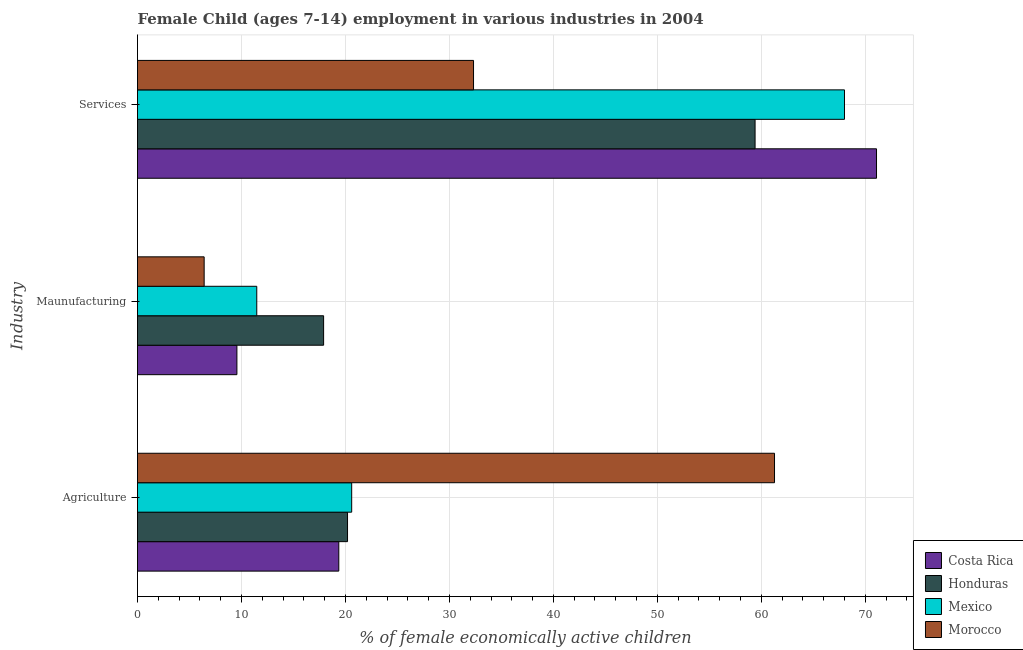How many different coloured bars are there?
Your answer should be compact. 4. How many bars are there on the 2nd tick from the top?
Your response must be concise. 4. What is the label of the 2nd group of bars from the top?
Keep it short and to the point. Maunufacturing. What is the percentage of economically active children in agriculture in Honduras?
Offer a very short reply. 20.2. Across all countries, what is the maximum percentage of economically active children in services?
Offer a very short reply. 71.08. Across all countries, what is the minimum percentage of economically active children in manufacturing?
Offer a terse response. 6.41. In which country was the percentage of economically active children in agriculture maximum?
Your response must be concise. Morocco. What is the total percentage of economically active children in agriculture in the graph?
Your answer should be very brief. 121.43. What is the difference between the percentage of economically active children in agriculture in Costa Rica and that in Morocco?
Your answer should be very brief. -41.91. What is the difference between the percentage of economically active children in agriculture in Morocco and the percentage of economically active children in manufacturing in Honduras?
Your answer should be compact. 43.37. What is the average percentage of economically active children in agriculture per country?
Offer a terse response. 30.36. What is the difference between the percentage of economically active children in services and percentage of economically active children in manufacturing in Mexico?
Give a very brief answer. 56.53. What is the ratio of the percentage of economically active children in manufacturing in Honduras to that in Mexico?
Provide a short and direct response. 1.56. Is the percentage of economically active children in agriculture in Morocco less than that in Honduras?
Your response must be concise. No. What is the difference between the highest and the second highest percentage of economically active children in agriculture?
Ensure brevity in your answer.  40.67. What is the difference between the highest and the lowest percentage of economically active children in services?
Give a very brief answer. 38.76. Is the sum of the percentage of economically active children in agriculture in Mexico and Honduras greater than the maximum percentage of economically active children in manufacturing across all countries?
Make the answer very short. Yes. What does the 3rd bar from the top in Services represents?
Keep it short and to the point. Honduras. What does the 4th bar from the bottom in Maunufacturing represents?
Your answer should be very brief. Morocco. How many bars are there?
Provide a succinct answer. 12. How many countries are there in the graph?
Make the answer very short. 4. What is the difference between two consecutive major ticks on the X-axis?
Provide a succinct answer. 10. Are the values on the major ticks of X-axis written in scientific E-notation?
Give a very brief answer. No. Does the graph contain grids?
Ensure brevity in your answer.  Yes. How many legend labels are there?
Your response must be concise. 4. How are the legend labels stacked?
Ensure brevity in your answer.  Vertical. What is the title of the graph?
Make the answer very short. Female Child (ages 7-14) employment in various industries in 2004. Does "Korea (Republic)" appear as one of the legend labels in the graph?
Make the answer very short. No. What is the label or title of the X-axis?
Make the answer very short. % of female economically active children. What is the label or title of the Y-axis?
Your response must be concise. Industry. What is the % of female economically active children in Costa Rica in Agriculture?
Keep it short and to the point. 19.36. What is the % of female economically active children in Honduras in Agriculture?
Offer a terse response. 20.2. What is the % of female economically active children of Mexico in Agriculture?
Your answer should be compact. 20.6. What is the % of female economically active children of Morocco in Agriculture?
Offer a very short reply. 61.27. What is the % of female economically active children of Costa Rica in Maunufacturing?
Provide a succinct answer. 9.56. What is the % of female economically active children of Mexico in Maunufacturing?
Keep it short and to the point. 11.47. What is the % of female economically active children of Morocco in Maunufacturing?
Offer a terse response. 6.41. What is the % of female economically active children in Costa Rica in Services?
Your response must be concise. 71.08. What is the % of female economically active children in Honduras in Services?
Your answer should be compact. 59.4. What is the % of female economically active children in Mexico in Services?
Give a very brief answer. 68. What is the % of female economically active children in Morocco in Services?
Offer a terse response. 32.32. Across all Industry, what is the maximum % of female economically active children of Costa Rica?
Provide a short and direct response. 71.08. Across all Industry, what is the maximum % of female economically active children of Honduras?
Offer a terse response. 59.4. Across all Industry, what is the maximum % of female economically active children of Morocco?
Provide a succinct answer. 61.27. Across all Industry, what is the minimum % of female economically active children of Costa Rica?
Your answer should be very brief. 9.56. Across all Industry, what is the minimum % of female economically active children in Mexico?
Ensure brevity in your answer.  11.47. Across all Industry, what is the minimum % of female economically active children of Morocco?
Your answer should be compact. 6.41. What is the total % of female economically active children in Costa Rica in the graph?
Your answer should be very brief. 100. What is the total % of female economically active children of Honduras in the graph?
Make the answer very short. 97.5. What is the total % of female economically active children of Mexico in the graph?
Make the answer very short. 100.07. What is the difference between the % of female economically active children in Mexico in Agriculture and that in Maunufacturing?
Offer a terse response. 9.13. What is the difference between the % of female economically active children of Morocco in Agriculture and that in Maunufacturing?
Your answer should be very brief. 54.86. What is the difference between the % of female economically active children of Costa Rica in Agriculture and that in Services?
Your answer should be very brief. -51.72. What is the difference between the % of female economically active children of Honduras in Agriculture and that in Services?
Keep it short and to the point. -39.2. What is the difference between the % of female economically active children of Mexico in Agriculture and that in Services?
Give a very brief answer. -47.4. What is the difference between the % of female economically active children in Morocco in Agriculture and that in Services?
Make the answer very short. 28.95. What is the difference between the % of female economically active children in Costa Rica in Maunufacturing and that in Services?
Give a very brief answer. -61.52. What is the difference between the % of female economically active children in Honduras in Maunufacturing and that in Services?
Your answer should be compact. -41.5. What is the difference between the % of female economically active children in Mexico in Maunufacturing and that in Services?
Give a very brief answer. -56.53. What is the difference between the % of female economically active children in Morocco in Maunufacturing and that in Services?
Provide a succinct answer. -25.91. What is the difference between the % of female economically active children in Costa Rica in Agriculture and the % of female economically active children in Honduras in Maunufacturing?
Give a very brief answer. 1.46. What is the difference between the % of female economically active children in Costa Rica in Agriculture and the % of female economically active children in Mexico in Maunufacturing?
Give a very brief answer. 7.89. What is the difference between the % of female economically active children in Costa Rica in Agriculture and the % of female economically active children in Morocco in Maunufacturing?
Provide a short and direct response. 12.95. What is the difference between the % of female economically active children of Honduras in Agriculture and the % of female economically active children of Mexico in Maunufacturing?
Ensure brevity in your answer.  8.73. What is the difference between the % of female economically active children in Honduras in Agriculture and the % of female economically active children in Morocco in Maunufacturing?
Offer a very short reply. 13.79. What is the difference between the % of female economically active children in Mexico in Agriculture and the % of female economically active children in Morocco in Maunufacturing?
Keep it short and to the point. 14.19. What is the difference between the % of female economically active children in Costa Rica in Agriculture and the % of female economically active children in Honduras in Services?
Your response must be concise. -40.04. What is the difference between the % of female economically active children in Costa Rica in Agriculture and the % of female economically active children in Mexico in Services?
Provide a succinct answer. -48.64. What is the difference between the % of female economically active children in Costa Rica in Agriculture and the % of female economically active children in Morocco in Services?
Offer a terse response. -12.96. What is the difference between the % of female economically active children in Honduras in Agriculture and the % of female economically active children in Mexico in Services?
Your answer should be very brief. -47.8. What is the difference between the % of female economically active children of Honduras in Agriculture and the % of female economically active children of Morocco in Services?
Your answer should be compact. -12.12. What is the difference between the % of female economically active children of Mexico in Agriculture and the % of female economically active children of Morocco in Services?
Offer a very short reply. -11.72. What is the difference between the % of female economically active children in Costa Rica in Maunufacturing and the % of female economically active children in Honduras in Services?
Provide a short and direct response. -49.84. What is the difference between the % of female economically active children of Costa Rica in Maunufacturing and the % of female economically active children of Mexico in Services?
Give a very brief answer. -58.44. What is the difference between the % of female economically active children of Costa Rica in Maunufacturing and the % of female economically active children of Morocco in Services?
Keep it short and to the point. -22.76. What is the difference between the % of female economically active children of Honduras in Maunufacturing and the % of female economically active children of Mexico in Services?
Your answer should be very brief. -50.1. What is the difference between the % of female economically active children of Honduras in Maunufacturing and the % of female economically active children of Morocco in Services?
Offer a very short reply. -14.42. What is the difference between the % of female economically active children of Mexico in Maunufacturing and the % of female economically active children of Morocco in Services?
Ensure brevity in your answer.  -20.85. What is the average % of female economically active children in Costa Rica per Industry?
Your answer should be compact. 33.33. What is the average % of female economically active children in Honduras per Industry?
Provide a succinct answer. 32.5. What is the average % of female economically active children in Mexico per Industry?
Give a very brief answer. 33.36. What is the average % of female economically active children of Morocco per Industry?
Provide a succinct answer. 33.33. What is the difference between the % of female economically active children of Costa Rica and % of female economically active children of Honduras in Agriculture?
Your response must be concise. -0.84. What is the difference between the % of female economically active children of Costa Rica and % of female economically active children of Mexico in Agriculture?
Provide a succinct answer. -1.24. What is the difference between the % of female economically active children of Costa Rica and % of female economically active children of Morocco in Agriculture?
Provide a short and direct response. -41.91. What is the difference between the % of female economically active children of Honduras and % of female economically active children of Mexico in Agriculture?
Offer a very short reply. -0.4. What is the difference between the % of female economically active children of Honduras and % of female economically active children of Morocco in Agriculture?
Keep it short and to the point. -41.07. What is the difference between the % of female economically active children of Mexico and % of female economically active children of Morocco in Agriculture?
Your answer should be very brief. -40.67. What is the difference between the % of female economically active children of Costa Rica and % of female economically active children of Honduras in Maunufacturing?
Provide a short and direct response. -8.34. What is the difference between the % of female economically active children of Costa Rica and % of female economically active children of Mexico in Maunufacturing?
Give a very brief answer. -1.91. What is the difference between the % of female economically active children of Costa Rica and % of female economically active children of Morocco in Maunufacturing?
Provide a succinct answer. 3.15. What is the difference between the % of female economically active children in Honduras and % of female economically active children in Mexico in Maunufacturing?
Give a very brief answer. 6.43. What is the difference between the % of female economically active children in Honduras and % of female economically active children in Morocco in Maunufacturing?
Your answer should be compact. 11.49. What is the difference between the % of female economically active children in Mexico and % of female economically active children in Morocco in Maunufacturing?
Provide a succinct answer. 5.06. What is the difference between the % of female economically active children of Costa Rica and % of female economically active children of Honduras in Services?
Make the answer very short. 11.68. What is the difference between the % of female economically active children in Costa Rica and % of female economically active children in Mexico in Services?
Keep it short and to the point. 3.08. What is the difference between the % of female economically active children in Costa Rica and % of female economically active children in Morocco in Services?
Provide a succinct answer. 38.76. What is the difference between the % of female economically active children of Honduras and % of female economically active children of Morocco in Services?
Provide a succinct answer. 27.08. What is the difference between the % of female economically active children of Mexico and % of female economically active children of Morocco in Services?
Make the answer very short. 35.68. What is the ratio of the % of female economically active children in Costa Rica in Agriculture to that in Maunufacturing?
Make the answer very short. 2.03. What is the ratio of the % of female economically active children in Honduras in Agriculture to that in Maunufacturing?
Keep it short and to the point. 1.13. What is the ratio of the % of female economically active children of Mexico in Agriculture to that in Maunufacturing?
Your answer should be very brief. 1.8. What is the ratio of the % of female economically active children in Morocco in Agriculture to that in Maunufacturing?
Your answer should be very brief. 9.56. What is the ratio of the % of female economically active children of Costa Rica in Agriculture to that in Services?
Offer a terse response. 0.27. What is the ratio of the % of female economically active children in Honduras in Agriculture to that in Services?
Offer a very short reply. 0.34. What is the ratio of the % of female economically active children in Mexico in Agriculture to that in Services?
Your answer should be compact. 0.3. What is the ratio of the % of female economically active children of Morocco in Agriculture to that in Services?
Make the answer very short. 1.9. What is the ratio of the % of female economically active children of Costa Rica in Maunufacturing to that in Services?
Make the answer very short. 0.13. What is the ratio of the % of female economically active children in Honduras in Maunufacturing to that in Services?
Offer a very short reply. 0.3. What is the ratio of the % of female economically active children in Mexico in Maunufacturing to that in Services?
Keep it short and to the point. 0.17. What is the ratio of the % of female economically active children in Morocco in Maunufacturing to that in Services?
Ensure brevity in your answer.  0.2. What is the difference between the highest and the second highest % of female economically active children of Costa Rica?
Keep it short and to the point. 51.72. What is the difference between the highest and the second highest % of female economically active children of Honduras?
Provide a succinct answer. 39.2. What is the difference between the highest and the second highest % of female economically active children of Mexico?
Your response must be concise. 47.4. What is the difference between the highest and the second highest % of female economically active children of Morocco?
Offer a terse response. 28.95. What is the difference between the highest and the lowest % of female economically active children of Costa Rica?
Your response must be concise. 61.52. What is the difference between the highest and the lowest % of female economically active children of Honduras?
Keep it short and to the point. 41.5. What is the difference between the highest and the lowest % of female economically active children of Mexico?
Your answer should be very brief. 56.53. What is the difference between the highest and the lowest % of female economically active children in Morocco?
Your answer should be very brief. 54.86. 